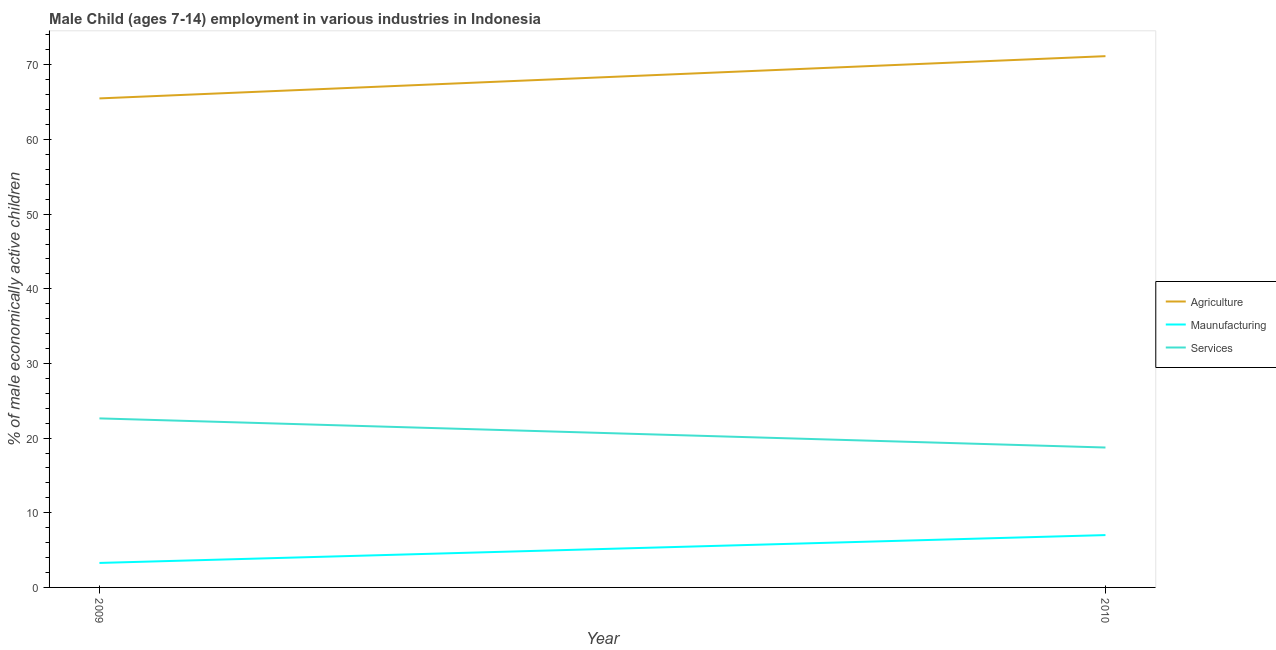How many different coloured lines are there?
Ensure brevity in your answer.  3. Does the line corresponding to percentage of economically active children in agriculture intersect with the line corresponding to percentage of economically active children in manufacturing?
Provide a short and direct response. No. Is the number of lines equal to the number of legend labels?
Offer a very short reply. Yes. What is the percentage of economically active children in services in 2009?
Offer a very short reply. 22.64. Across all years, what is the maximum percentage of economically active children in agriculture?
Offer a very short reply. 71.16. Across all years, what is the minimum percentage of economically active children in manufacturing?
Your answer should be compact. 3.28. What is the total percentage of economically active children in services in the graph?
Provide a succinct answer. 41.38. What is the difference between the percentage of economically active children in manufacturing in 2009 and that in 2010?
Provide a short and direct response. -3.73. What is the difference between the percentage of economically active children in agriculture in 2010 and the percentage of economically active children in services in 2009?
Make the answer very short. 48.52. What is the average percentage of economically active children in services per year?
Ensure brevity in your answer.  20.69. In the year 2009, what is the difference between the percentage of economically active children in agriculture and percentage of economically active children in manufacturing?
Offer a terse response. 62.22. What is the ratio of the percentage of economically active children in manufacturing in 2009 to that in 2010?
Offer a very short reply. 0.47. In how many years, is the percentage of economically active children in agriculture greater than the average percentage of economically active children in agriculture taken over all years?
Your answer should be very brief. 1. Does the percentage of economically active children in manufacturing monotonically increase over the years?
Provide a short and direct response. Yes. Is the percentage of economically active children in manufacturing strictly greater than the percentage of economically active children in agriculture over the years?
Your response must be concise. No. How many lines are there?
Give a very brief answer. 3. Are the values on the major ticks of Y-axis written in scientific E-notation?
Offer a terse response. No. Does the graph contain grids?
Give a very brief answer. No. Where does the legend appear in the graph?
Your response must be concise. Center right. How many legend labels are there?
Your answer should be compact. 3. How are the legend labels stacked?
Offer a terse response. Vertical. What is the title of the graph?
Provide a succinct answer. Male Child (ages 7-14) employment in various industries in Indonesia. Does "Labor Market" appear as one of the legend labels in the graph?
Your answer should be compact. No. What is the label or title of the Y-axis?
Offer a terse response. % of male economically active children. What is the % of male economically active children in Agriculture in 2009?
Your response must be concise. 65.5. What is the % of male economically active children of Maunufacturing in 2009?
Offer a very short reply. 3.28. What is the % of male economically active children of Services in 2009?
Make the answer very short. 22.64. What is the % of male economically active children of Agriculture in 2010?
Ensure brevity in your answer.  71.16. What is the % of male economically active children of Maunufacturing in 2010?
Your answer should be very brief. 7.01. What is the % of male economically active children of Services in 2010?
Make the answer very short. 18.74. Across all years, what is the maximum % of male economically active children of Agriculture?
Ensure brevity in your answer.  71.16. Across all years, what is the maximum % of male economically active children of Maunufacturing?
Ensure brevity in your answer.  7.01. Across all years, what is the maximum % of male economically active children of Services?
Your answer should be compact. 22.64. Across all years, what is the minimum % of male economically active children in Agriculture?
Ensure brevity in your answer.  65.5. Across all years, what is the minimum % of male economically active children of Maunufacturing?
Provide a short and direct response. 3.28. Across all years, what is the minimum % of male economically active children of Services?
Provide a short and direct response. 18.74. What is the total % of male economically active children in Agriculture in the graph?
Your response must be concise. 136.66. What is the total % of male economically active children of Maunufacturing in the graph?
Your response must be concise. 10.29. What is the total % of male economically active children in Services in the graph?
Offer a terse response. 41.38. What is the difference between the % of male economically active children in Agriculture in 2009 and that in 2010?
Your answer should be very brief. -5.66. What is the difference between the % of male economically active children in Maunufacturing in 2009 and that in 2010?
Provide a short and direct response. -3.73. What is the difference between the % of male economically active children of Agriculture in 2009 and the % of male economically active children of Maunufacturing in 2010?
Ensure brevity in your answer.  58.49. What is the difference between the % of male economically active children in Agriculture in 2009 and the % of male economically active children in Services in 2010?
Ensure brevity in your answer.  46.76. What is the difference between the % of male economically active children in Maunufacturing in 2009 and the % of male economically active children in Services in 2010?
Your response must be concise. -15.46. What is the average % of male economically active children of Agriculture per year?
Give a very brief answer. 68.33. What is the average % of male economically active children of Maunufacturing per year?
Offer a very short reply. 5.14. What is the average % of male economically active children in Services per year?
Give a very brief answer. 20.69. In the year 2009, what is the difference between the % of male economically active children in Agriculture and % of male economically active children in Maunufacturing?
Provide a short and direct response. 62.22. In the year 2009, what is the difference between the % of male economically active children in Agriculture and % of male economically active children in Services?
Give a very brief answer. 42.86. In the year 2009, what is the difference between the % of male economically active children in Maunufacturing and % of male economically active children in Services?
Your answer should be very brief. -19.36. In the year 2010, what is the difference between the % of male economically active children in Agriculture and % of male economically active children in Maunufacturing?
Your answer should be compact. 64.15. In the year 2010, what is the difference between the % of male economically active children in Agriculture and % of male economically active children in Services?
Provide a succinct answer. 52.42. In the year 2010, what is the difference between the % of male economically active children in Maunufacturing and % of male economically active children in Services?
Provide a succinct answer. -11.73. What is the ratio of the % of male economically active children in Agriculture in 2009 to that in 2010?
Keep it short and to the point. 0.92. What is the ratio of the % of male economically active children of Maunufacturing in 2009 to that in 2010?
Your response must be concise. 0.47. What is the ratio of the % of male economically active children in Services in 2009 to that in 2010?
Provide a succinct answer. 1.21. What is the difference between the highest and the second highest % of male economically active children in Agriculture?
Your answer should be very brief. 5.66. What is the difference between the highest and the second highest % of male economically active children in Maunufacturing?
Provide a short and direct response. 3.73. What is the difference between the highest and the lowest % of male economically active children of Agriculture?
Give a very brief answer. 5.66. What is the difference between the highest and the lowest % of male economically active children in Maunufacturing?
Make the answer very short. 3.73. 